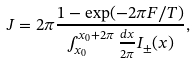<formula> <loc_0><loc_0><loc_500><loc_500>J = 2 \pi \frac { 1 - \exp ( - 2 \pi F / T ) } { \int ^ { x _ { 0 } + 2 \pi } _ { x _ { 0 } } \frac { d x } { 2 \pi } I _ { \pm } ( x ) } , \\</formula> 